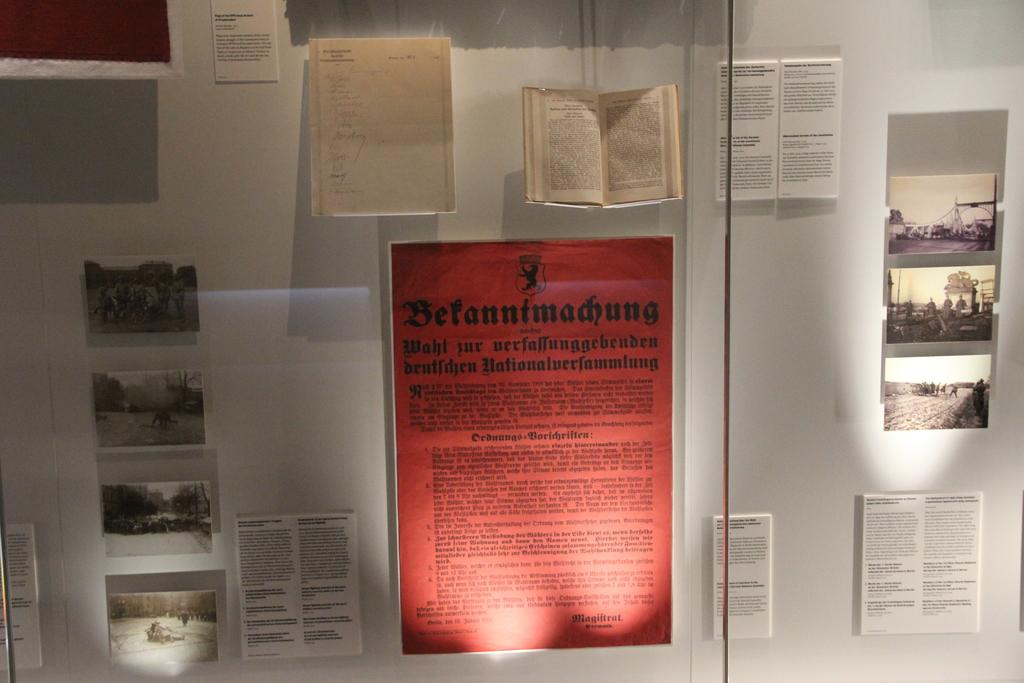<image>
Give a short and clear explanation of the subsequent image. A red sheet of paper in the middle of the display has the German word Bekanntmachung at the top. 